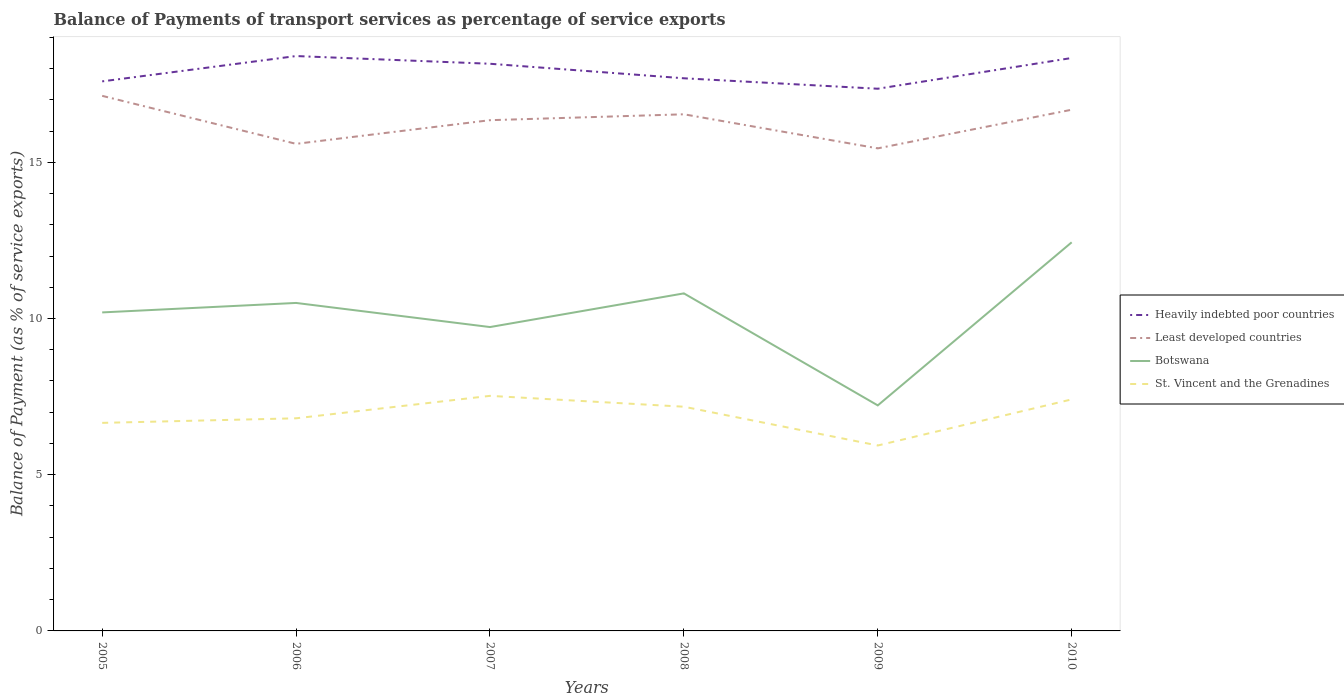How many different coloured lines are there?
Keep it short and to the point. 4. Does the line corresponding to Heavily indebted poor countries intersect with the line corresponding to Botswana?
Provide a short and direct response. No. Across all years, what is the maximum balance of payments of transport services in Botswana?
Offer a terse response. 7.22. What is the total balance of payments of transport services in Least developed countries in the graph?
Your answer should be compact. -1.09. What is the difference between the highest and the second highest balance of payments of transport services in Least developed countries?
Keep it short and to the point. 1.68. How many lines are there?
Give a very brief answer. 4. Are the values on the major ticks of Y-axis written in scientific E-notation?
Give a very brief answer. No. Does the graph contain any zero values?
Ensure brevity in your answer.  No. Does the graph contain grids?
Give a very brief answer. No. Where does the legend appear in the graph?
Provide a succinct answer. Center right. How are the legend labels stacked?
Your answer should be compact. Vertical. What is the title of the graph?
Your answer should be very brief. Balance of Payments of transport services as percentage of service exports. What is the label or title of the X-axis?
Give a very brief answer. Years. What is the label or title of the Y-axis?
Keep it short and to the point. Balance of Payment (as % of service exports). What is the Balance of Payment (as % of service exports) of Heavily indebted poor countries in 2005?
Provide a succinct answer. 17.59. What is the Balance of Payment (as % of service exports) of Least developed countries in 2005?
Your response must be concise. 17.13. What is the Balance of Payment (as % of service exports) in Botswana in 2005?
Your answer should be compact. 10.2. What is the Balance of Payment (as % of service exports) of St. Vincent and the Grenadines in 2005?
Your answer should be compact. 6.66. What is the Balance of Payment (as % of service exports) of Heavily indebted poor countries in 2006?
Offer a terse response. 18.4. What is the Balance of Payment (as % of service exports) in Least developed countries in 2006?
Provide a succinct answer. 15.59. What is the Balance of Payment (as % of service exports) in Botswana in 2006?
Give a very brief answer. 10.5. What is the Balance of Payment (as % of service exports) in St. Vincent and the Grenadines in 2006?
Provide a succinct answer. 6.81. What is the Balance of Payment (as % of service exports) of Heavily indebted poor countries in 2007?
Your response must be concise. 18.15. What is the Balance of Payment (as % of service exports) in Least developed countries in 2007?
Make the answer very short. 16.35. What is the Balance of Payment (as % of service exports) of Botswana in 2007?
Offer a terse response. 9.73. What is the Balance of Payment (as % of service exports) in St. Vincent and the Grenadines in 2007?
Ensure brevity in your answer.  7.52. What is the Balance of Payment (as % of service exports) in Heavily indebted poor countries in 2008?
Your answer should be compact. 17.69. What is the Balance of Payment (as % of service exports) of Least developed countries in 2008?
Offer a terse response. 16.54. What is the Balance of Payment (as % of service exports) in Botswana in 2008?
Keep it short and to the point. 10.8. What is the Balance of Payment (as % of service exports) in St. Vincent and the Grenadines in 2008?
Your answer should be compact. 7.18. What is the Balance of Payment (as % of service exports) in Heavily indebted poor countries in 2009?
Your response must be concise. 17.36. What is the Balance of Payment (as % of service exports) in Least developed countries in 2009?
Keep it short and to the point. 15.45. What is the Balance of Payment (as % of service exports) of Botswana in 2009?
Your answer should be compact. 7.22. What is the Balance of Payment (as % of service exports) of St. Vincent and the Grenadines in 2009?
Make the answer very short. 5.94. What is the Balance of Payment (as % of service exports) of Heavily indebted poor countries in 2010?
Your response must be concise. 18.34. What is the Balance of Payment (as % of service exports) of Least developed countries in 2010?
Make the answer very short. 16.68. What is the Balance of Payment (as % of service exports) of Botswana in 2010?
Keep it short and to the point. 12.44. What is the Balance of Payment (as % of service exports) in St. Vincent and the Grenadines in 2010?
Your answer should be very brief. 7.41. Across all years, what is the maximum Balance of Payment (as % of service exports) of Heavily indebted poor countries?
Keep it short and to the point. 18.4. Across all years, what is the maximum Balance of Payment (as % of service exports) in Least developed countries?
Your answer should be very brief. 17.13. Across all years, what is the maximum Balance of Payment (as % of service exports) of Botswana?
Provide a short and direct response. 12.44. Across all years, what is the maximum Balance of Payment (as % of service exports) of St. Vincent and the Grenadines?
Your answer should be compact. 7.52. Across all years, what is the minimum Balance of Payment (as % of service exports) of Heavily indebted poor countries?
Offer a very short reply. 17.36. Across all years, what is the minimum Balance of Payment (as % of service exports) in Least developed countries?
Offer a very short reply. 15.45. Across all years, what is the minimum Balance of Payment (as % of service exports) of Botswana?
Your answer should be very brief. 7.22. Across all years, what is the minimum Balance of Payment (as % of service exports) of St. Vincent and the Grenadines?
Offer a terse response. 5.94. What is the total Balance of Payment (as % of service exports) of Heavily indebted poor countries in the graph?
Your response must be concise. 107.53. What is the total Balance of Payment (as % of service exports) in Least developed countries in the graph?
Offer a very short reply. 97.73. What is the total Balance of Payment (as % of service exports) in Botswana in the graph?
Provide a succinct answer. 60.88. What is the total Balance of Payment (as % of service exports) in St. Vincent and the Grenadines in the graph?
Give a very brief answer. 41.51. What is the difference between the Balance of Payment (as % of service exports) in Heavily indebted poor countries in 2005 and that in 2006?
Your answer should be very brief. -0.81. What is the difference between the Balance of Payment (as % of service exports) of Least developed countries in 2005 and that in 2006?
Give a very brief answer. 1.54. What is the difference between the Balance of Payment (as % of service exports) in Botswana in 2005 and that in 2006?
Your answer should be compact. -0.3. What is the difference between the Balance of Payment (as % of service exports) of St. Vincent and the Grenadines in 2005 and that in 2006?
Your answer should be very brief. -0.15. What is the difference between the Balance of Payment (as % of service exports) of Heavily indebted poor countries in 2005 and that in 2007?
Give a very brief answer. -0.56. What is the difference between the Balance of Payment (as % of service exports) in Least developed countries in 2005 and that in 2007?
Ensure brevity in your answer.  0.78. What is the difference between the Balance of Payment (as % of service exports) in Botswana in 2005 and that in 2007?
Your answer should be very brief. 0.47. What is the difference between the Balance of Payment (as % of service exports) in St. Vincent and the Grenadines in 2005 and that in 2007?
Offer a very short reply. -0.87. What is the difference between the Balance of Payment (as % of service exports) in Heavily indebted poor countries in 2005 and that in 2008?
Offer a very short reply. -0.1. What is the difference between the Balance of Payment (as % of service exports) in Least developed countries in 2005 and that in 2008?
Make the answer very short. 0.59. What is the difference between the Balance of Payment (as % of service exports) in Botswana in 2005 and that in 2008?
Your answer should be compact. -0.61. What is the difference between the Balance of Payment (as % of service exports) in St. Vincent and the Grenadines in 2005 and that in 2008?
Give a very brief answer. -0.52. What is the difference between the Balance of Payment (as % of service exports) of Heavily indebted poor countries in 2005 and that in 2009?
Offer a very short reply. 0.24. What is the difference between the Balance of Payment (as % of service exports) in Least developed countries in 2005 and that in 2009?
Offer a terse response. 1.68. What is the difference between the Balance of Payment (as % of service exports) in Botswana in 2005 and that in 2009?
Your response must be concise. 2.98. What is the difference between the Balance of Payment (as % of service exports) of St. Vincent and the Grenadines in 2005 and that in 2009?
Provide a short and direct response. 0.72. What is the difference between the Balance of Payment (as % of service exports) in Heavily indebted poor countries in 2005 and that in 2010?
Your answer should be very brief. -0.75. What is the difference between the Balance of Payment (as % of service exports) in Least developed countries in 2005 and that in 2010?
Keep it short and to the point. 0.44. What is the difference between the Balance of Payment (as % of service exports) in Botswana in 2005 and that in 2010?
Your answer should be very brief. -2.24. What is the difference between the Balance of Payment (as % of service exports) of St. Vincent and the Grenadines in 2005 and that in 2010?
Ensure brevity in your answer.  -0.75. What is the difference between the Balance of Payment (as % of service exports) of Heavily indebted poor countries in 2006 and that in 2007?
Your answer should be very brief. 0.25. What is the difference between the Balance of Payment (as % of service exports) of Least developed countries in 2006 and that in 2007?
Offer a very short reply. -0.76. What is the difference between the Balance of Payment (as % of service exports) of Botswana in 2006 and that in 2007?
Provide a succinct answer. 0.77. What is the difference between the Balance of Payment (as % of service exports) of St. Vincent and the Grenadines in 2006 and that in 2007?
Provide a short and direct response. -0.72. What is the difference between the Balance of Payment (as % of service exports) in Heavily indebted poor countries in 2006 and that in 2008?
Keep it short and to the point. 0.71. What is the difference between the Balance of Payment (as % of service exports) in Least developed countries in 2006 and that in 2008?
Make the answer very short. -0.95. What is the difference between the Balance of Payment (as % of service exports) of Botswana in 2006 and that in 2008?
Keep it short and to the point. -0.31. What is the difference between the Balance of Payment (as % of service exports) in St. Vincent and the Grenadines in 2006 and that in 2008?
Keep it short and to the point. -0.37. What is the difference between the Balance of Payment (as % of service exports) of Heavily indebted poor countries in 2006 and that in 2009?
Your response must be concise. 1.05. What is the difference between the Balance of Payment (as % of service exports) in Least developed countries in 2006 and that in 2009?
Provide a succinct answer. 0.14. What is the difference between the Balance of Payment (as % of service exports) of Botswana in 2006 and that in 2009?
Ensure brevity in your answer.  3.28. What is the difference between the Balance of Payment (as % of service exports) of St. Vincent and the Grenadines in 2006 and that in 2009?
Make the answer very short. 0.87. What is the difference between the Balance of Payment (as % of service exports) of Heavily indebted poor countries in 2006 and that in 2010?
Give a very brief answer. 0.06. What is the difference between the Balance of Payment (as % of service exports) in Least developed countries in 2006 and that in 2010?
Offer a terse response. -1.09. What is the difference between the Balance of Payment (as % of service exports) in Botswana in 2006 and that in 2010?
Provide a short and direct response. -1.94. What is the difference between the Balance of Payment (as % of service exports) in St. Vincent and the Grenadines in 2006 and that in 2010?
Your answer should be very brief. -0.61. What is the difference between the Balance of Payment (as % of service exports) in Heavily indebted poor countries in 2007 and that in 2008?
Keep it short and to the point. 0.47. What is the difference between the Balance of Payment (as % of service exports) in Least developed countries in 2007 and that in 2008?
Your answer should be compact. -0.19. What is the difference between the Balance of Payment (as % of service exports) in Botswana in 2007 and that in 2008?
Offer a very short reply. -1.08. What is the difference between the Balance of Payment (as % of service exports) in St. Vincent and the Grenadines in 2007 and that in 2008?
Your response must be concise. 0.35. What is the difference between the Balance of Payment (as % of service exports) in Heavily indebted poor countries in 2007 and that in 2009?
Keep it short and to the point. 0.8. What is the difference between the Balance of Payment (as % of service exports) in Least developed countries in 2007 and that in 2009?
Offer a terse response. 0.9. What is the difference between the Balance of Payment (as % of service exports) of Botswana in 2007 and that in 2009?
Give a very brief answer. 2.51. What is the difference between the Balance of Payment (as % of service exports) of St. Vincent and the Grenadines in 2007 and that in 2009?
Ensure brevity in your answer.  1.59. What is the difference between the Balance of Payment (as % of service exports) in Heavily indebted poor countries in 2007 and that in 2010?
Provide a succinct answer. -0.18. What is the difference between the Balance of Payment (as % of service exports) of Least developed countries in 2007 and that in 2010?
Ensure brevity in your answer.  -0.33. What is the difference between the Balance of Payment (as % of service exports) in Botswana in 2007 and that in 2010?
Keep it short and to the point. -2.71. What is the difference between the Balance of Payment (as % of service exports) in St. Vincent and the Grenadines in 2007 and that in 2010?
Make the answer very short. 0.11. What is the difference between the Balance of Payment (as % of service exports) of Heavily indebted poor countries in 2008 and that in 2009?
Keep it short and to the point. 0.33. What is the difference between the Balance of Payment (as % of service exports) in Least developed countries in 2008 and that in 2009?
Your answer should be very brief. 1.09. What is the difference between the Balance of Payment (as % of service exports) in Botswana in 2008 and that in 2009?
Offer a very short reply. 3.59. What is the difference between the Balance of Payment (as % of service exports) in St. Vincent and the Grenadines in 2008 and that in 2009?
Provide a short and direct response. 1.24. What is the difference between the Balance of Payment (as % of service exports) of Heavily indebted poor countries in 2008 and that in 2010?
Make the answer very short. -0.65. What is the difference between the Balance of Payment (as % of service exports) in Least developed countries in 2008 and that in 2010?
Make the answer very short. -0.15. What is the difference between the Balance of Payment (as % of service exports) in Botswana in 2008 and that in 2010?
Your answer should be very brief. -1.63. What is the difference between the Balance of Payment (as % of service exports) of St. Vincent and the Grenadines in 2008 and that in 2010?
Offer a terse response. -0.23. What is the difference between the Balance of Payment (as % of service exports) of Heavily indebted poor countries in 2009 and that in 2010?
Offer a terse response. -0.98. What is the difference between the Balance of Payment (as % of service exports) in Least developed countries in 2009 and that in 2010?
Make the answer very short. -1.24. What is the difference between the Balance of Payment (as % of service exports) of Botswana in 2009 and that in 2010?
Your response must be concise. -5.22. What is the difference between the Balance of Payment (as % of service exports) of St. Vincent and the Grenadines in 2009 and that in 2010?
Your answer should be compact. -1.48. What is the difference between the Balance of Payment (as % of service exports) of Heavily indebted poor countries in 2005 and the Balance of Payment (as % of service exports) of Least developed countries in 2006?
Keep it short and to the point. 2. What is the difference between the Balance of Payment (as % of service exports) of Heavily indebted poor countries in 2005 and the Balance of Payment (as % of service exports) of Botswana in 2006?
Offer a terse response. 7.09. What is the difference between the Balance of Payment (as % of service exports) of Heavily indebted poor countries in 2005 and the Balance of Payment (as % of service exports) of St. Vincent and the Grenadines in 2006?
Offer a very short reply. 10.78. What is the difference between the Balance of Payment (as % of service exports) of Least developed countries in 2005 and the Balance of Payment (as % of service exports) of Botswana in 2006?
Give a very brief answer. 6.63. What is the difference between the Balance of Payment (as % of service exports) of Least developed countries in 2005 and the Balance of Payment (as % of service exports) of St. Vincent and the Grenadines in 2006?
Make the answer very short. 10.32. What is the difference between the Balance of Payment (as % of service exports) of Botswana in 2005 and the Balance of Payment (as % of service exports) of St. Vincent and the Grenadines in 2006?
Make the answer very short. 3.39. What is the difference between the Balance of Payment (as % of service exports) in Heavily indebted poor countries in 2005 and the Balance of Payment (as % of service exports) in Least developed countries in 2007?
Your answer should be very brief. 1.24. What is the difference between the Balance of Payment (as % of service exports) of Heavily indebted poor countries in 2005 and the Balance of Payment (as % of service exports) of Botswana in 2007?
Give a very brief answer. 7.86. What is the difference between the Balance of Payment (as % of service exports) of Heavily indebted poor countries in 2005 and the Balance of Payment (as % of service exports) of St. Vincent and the Grenadines in 2007?
Your answer should be very brief. 10.07. What is the difference between the Balance of Payment (as % of service exports) of Least developed countries in 2005 and the Balance of Payment (as % of service exports) of Botswana in 2007?
Provide a short and direct response. 7.4. What is the difference between the Balance of Payment (as % of service exports) in Least developed countries in 2005 and the Balance of Payment (as % of service exports) in St. Vincent and the Grenadines in 2007?
Give a very brief answer. 9.6. What is the difference between the Balance of Payment (as % of service exports) of Botswana in 2005 and the Balance of Payment (as % of service exports) of St. Vincent and the Grenadines in 2007?
Your response must be concise. 2.67. What is the difference between the Balance of Payment (as % of service exports) in Heavily indebted poor countries in 2005 and the Balance of Payment (as % of service exports) in Least developed countries in 2008?
Give a very brief answer. 1.05. What is the difference between the Balance of Payment (as % of service exports) of Heavily indebted poor countries in 2005 and the Balance of Payment (as % of service exports) of Botswana in 2008?
Provide a succinct answer. 6.79. What is the difference between the Balance of Payment (as % of service exports) of Heavily indebted poor countries in 2005 and the Balance of Payment (as % of service exports) of St. Vincent and the Grenadines in 2008?
Your answer should be very brief. 10.41. What is the difference between the Balance of Payment (as % of service exports) of Least developed countries in 2005 and the Balance of Payment (as % of service exports) of Botswana in 2008?
Offer a terse response. 6.32. What is the difference between the Balance of Payment (as % of service exports) of Least developed countries in 2005 and the Balance of Payment (as % of service exports) of St. Vincent and the Grenadines in 2008?
Keep it short and to the point. 9.95. What is the difference between the Balance of Payment (as % of service exports) in Botswana in 2005 and the Balance of Payment (as % of service exports) in St. Vincent and the Grenadines in 2008?
Offer a very short reply. 3.02. What is the difference between the Balance of Payment (as % of service exports) in Heavily indebted poor countries in 2005 and the Balance of Payment (as % of service exports) in Least developed countries in 2009?
Offer a very short reply. 2.14. What is the difference between the Balance of Payment (as % of service exports) of Heavily indebted poor countries in 2005 and the Balance of Payment (as % of service exports) of Botswana in 2009?
Provide a short and direct response. 10.37. What is the difference between the Balance of Payment (as % of service exports) in Heavily indebted poor countries in 2005 and the Balance of Payment (as % of service exports) in St. Vincent and the Grenadines in 2009?
Offer a terse response. 11.66. What is the difference between the Balance of Payment (as % of service exports) in Least developed countries in 2005 and the Balance of Payment (as % of service exports) in Botswana in 2009?
Ensure brevity in your answer.  9.91. What is the difference between the Balance of Payment (as % of service exports) in Least developed countries in 2005 and the Balance of Payment (as % of service exports) in St. Vincent and the Grenadines in 2009?
Provide a succinct answer. 11.19. What is the difference between the Balance of Payment (as % of service exports) in Botswana in 2005 and the Balance of Payment (as % of service exports) in St. Vincent and the Grenadines in 2009?
Offer a very short reply. 4.26. What is the difference between the Balance of Payment (as % of service exports) in Heavily indebted poor countries in 2005 and the Balance of Payment (as % of service exports) in Least developed countries in 2010?
Ensure brevity in your answer.  0.91. What is the difference between the Balance of Payment (as % of service exports) of Heavily indebted poor countries in 2005 and the Balance of Payment (as % of service exports) of Botswana in 2010?
Ensure brevity in your answer.  5.15. What is the difference between the Balance of Payment (as % of service exports) of Heavily indebted poor countries in 2005 and the Balance of Payment (as % of service exports) of St. Vincent and the Grenadines in 2010?
Your answer should be compact. 10.18. What is the difference between the Balance of Payment (as % of service exports) of Least developed countries in 2005 and the Balance of Payment (as % of service exports) of Botswana in 2010?
Keep it short and to the point. 4.69. What is the difference between the Balance of Payment (as % of service exports) of Least developed countries in 2005 and the Balance of Payment (as % of service exports) of St. Vincent and the Grenadines in 2010?
Your response must be concise. 9.72. What is the difference between the Balance of Payment (as % of service exports) of Botswana in 2005 and the Balance of Payment (as % of service exports) of St. Vincent and the Grenadines in 2010?
Make the answer very short. 2.78. What is the difference between the Balance of Payment (as % of service exports) of Heavily indebted poor countries in 2006 and the Balance of Payment (as % of service exports) of Least developed countries in 2007?
Ensure brevity in your answer.  2.05. What is the difference between the Balance of Payment (as % of service exports) of Heavily indebted poor countries in 2006 and the Balance of Payment (as % of service exports) of Botswana in 2007?
Your answer should be very brief. 8.67. What is the difference between the Balance of Payment (as % of service exports) in Heavily indebted poor countries in 2006 and the Balance of Payment (as % of service exports) in St. Vincent and the Grenadines in 2007?
Offer a very short reply. 10.88. What is the difference between the Balance of Payment (as % of service exports) in Least developed countries in 2006 and the Balance of Payment (as % of service exports) in Botswana in 2007?
Your response must be concise. 5.86. What is the difference between the Balance of Payment (as % of service exports) of Least developed countries in 2006 and the Balance of Payment (as % of service exports) of St. Vincent and the Grenadines in 2007?
Make the answer very short. 8.07. What is the difference between the Balance of Payment (as % of service exports) of Botswana in 2006 and the Balance of Payment (as % of service exports) of St. Vincent and the Grenadines in 2007?
Ensure brevity in your answer.  2.97. What is the difference between the Balance of Payment (as % of service exports) in Heavily indebted poor countries in 2006 and the Balance of Payment (as % of service exports) in Least developed countries in 2008?
Provide a succinct answer. 1.86. What is the difference between the Balance of Payment (as % of service exports) in Heavily indebted poor countries in 2006 and the Balance of Payment (as % of service exports) in Botswana in 2008?
Offer a very short reply. 7.6. What is the difference between the Balance of Payment (as % of service exports) of Heavily indebted poor countries in 2006 and the Balance of Payment (as % of service exports) of St. Vincent and the Grenadines in 2008?
Offer a very short reply. 11.22. What is the difference between the Balance of Payment (as % of service exports) in Least developed countries in 2006 and the Balance of Payment (as % of service exports) in Botswana in 2008?
Make the answer very short. 4.79. What is the difference between the Balance of Payment (as % of service exports) of Least developed countries in 2006 and the Balance of Payment (as % of service exports) of St. Vincent and the Grenadines in 2008?
Provide a short and direct response. 8.41. What is the difference between the Balance of Payment (as % of service exports) in Botswana in 2006 and the Balance of Payment (as % of service exports) in St. Vincent and the Grenadines in 2008?
Provide a short and direct response. 3.32. What is the difference between the Balance of Payment (as % of service exports) in Heavily indebted poor countries in 2006 and the Balance of Payment (as % of service exports) in Least developed countries in 2009?
Ensure brevity in your answer.  2.95. What is the difference between the Balance of Payment (as % of service exports) in Heavily indebted poor countries in 2006 and the Balance of Payment (as % of service exports) in Botswana in 2009?
Keep it short and to the point. 11.18. What is the difference between the Balance of Payment (as % of service exports) of Heavily indebted poor countries in 2006 and the Balance of Payment (as % of service exports) of St. Vincent and the Grenadines in 2009?
Offer a very short reply. 12.47. What is the difference between the Balance of Payment (as % of service exports) in Least developed countries in 2006 and the Balance of Payment (as % of service exports) in Botswana in 2009?
Give a very brief answer. 8.37. What is the difference between the Balance of Payment (as % of service exports) in Least developed countries in 2006 and the Balance of Payment (as % of service exports) in St. Vincent and the Grenadines in 2009?
Give a very brief answer. 9.66. What is the difference between the Balance of Payment (as % of service exports) of Botswana in 2006 and the Balance of Payment (as % of service exports) of St. Vincent and the Grenadines in 2009?
Provide a succinct answer. 4.56. What is the difference between the Balance of Payment (as % of service exports) of Heavily indebted poor countries in 2006 and the Balance of Payment (as % of service exports) of Least developed countries in 2010?
Provide a succinct answer. 1.72. What is the difference between the Balance of Payment (as % of service exports) in Heavily indebted poor countries in 2006 and the Balance of Payment (as % of service exports) in Botswana in 2010?
Your answer should be very brief. 5.96. What is the difference between the Balance of Payment (as % of service exports) of Heavily indebted poor countries in 2006 and the Balance of Payment (as % of service exports) of St. Vincent and the Grenadines in 2010?
Provide a short and direct response. 10.99. What is the difference between the Balance of Payment (as % of service exports) of Least developed countries in 2006 and the Balance of Payment (as % of service exports) of Botswana in 2010?
Keep it short and to the point. 3.15. What is the difference between the Balance of Payment (as % of service exports) of Least developed countries in 2006 and the Balance of Payment (as % of service exports) of St. Vincent and the Grenadines in 2010?
Offer a very short reply. 8.18. What is the difference between the Balance of Payment (as % of service exports) of Botswana in 2006 and the Balance of Payment (as % of service exports) of St. Vincent and the Grenadines in 2010?
Ensure brevity in your answer.  3.09. What is the difference between the Balance of Payment (as % of service exports) in Heavily indebted poor countries in 2007 and the Balance of Payment (as % of service exports) in Least developed countries in 2008?
Your answer should be very brief. 1.62. What is the difference between the Balance of Payment (as % of service exports) in Heavily indebted poor countries in 2007 and the Balance of Payment (as % of service exports) in Botswana in 2008?
Keep it short and to the point. 7.35. What is the difference between the Balance of Payment (as % of service exports) in Heavily indebted poor countries in 2007 and the Balance of Payment (as % of service exports) in St. Vincent and the Grenadines in 2008?
Provide a succinct answer. 10.98. What is the difference between the Balance of Payment (as % of service exports) of Least developed countries in 2007 and the Balance of Payment (as % of service exports) of Botswana in 2008?
Your response must be concise. 5.54. What is the difference between the Balance of Payment (as % of service exports) of Least developed countries in 2007 and the Balance of Payment (as % of service exports) of St. Vincent and the Grenadines in 2008?
Your response must be concise. 9.17. What is the difference between the Balance of Payment (as % of service exports) of Botswana in 2007 and the Balance of Payment (as % of service exports) of St. Vincent and the Grenadines in 2008?
Provide a succinct answer. 2.55. What is the difference between the Balance of Payment (as % of service exports) of Heavily indebted poor countries in 2007 and the Balance of Payment (as % of service exports) of Least developed countries in 2009?
Your response must be concise. 2.71. What is the difference between the Balance of Payment (as % of service exports) of Heavily indebted poor countries in 2007 and the Balance of Payment (as % of service exports) of Botswana in 2009?
Provide a short and direct response. 10.94. What is the difference between the Balance of Payment (as % of service exports) in Heavily indebted poor countries in 2007 and the Balance of Payment (as % of service exports) in St. Vincent and the Grenadines in 2009?
Offer a terse response. 12.22. What is the difference between the Balance of Payment (as % of service exports) of Least developed countries in 2007 and the Balance of Payment (as % of service exports) of Botswana in 2009?
Offer a very short reply. 9.13. What is the difference between the Balance of Payment (as % of service exports) in Least developed countries in 2007 and the Balance of Payment (as % of service exports) in St. Vincent and the Grenadines in 2009?
Provide a succinct answer. 10.41. What is the difference between the Balance of Payment (as % of service exports) in Botswana in 2007 and the Balance of Payment (as % of service exports) in St. Vincent and the Grenadines in 2009?
Provide a short and direct response. 3.79. What is the difference between the Balance of Payment (as % of service exports) of Heavily indebted poor countries in 2007 and the Balance of Payment (as % of service exports) of Least developed countries in 2010?
Your answer should be compact. 1.47. What is the difference between the Balance of Payment (as % of service exports) of Heavily indebted poor countries in 2007 and the Balance of Payment (as % of service exports) of Botswana in 2010?
Offer a terse response. 5.72. What is the difference between the Balance of Payment (as % of service exports) in Heavily indebted poor countries in 2007 and the Balance of Payment (as % of service exports) in St. Vincent and the Grenadines in 2010?
Provide a succinct answer. 10.74. What is the difference between the Balance of Payment (as % of service exports) in Least developed countries in 2007 and the Balance of Payment (as % of service exports) in Botswana in 2010?
Give a very brief answer. 3.91. What is the difference between the Balance of Payment (as % of service exports) in Least developed countries in 2007 and the Balance of Payment (as % of service exports) in St. Vincent and the Grenadines in 2010?
Offer a very short reply. 8.94. What is the difference between the Balance of Payment (as % of service exports) in Botswana in 2007 and the Balance of Payment (as % of service exports) in St. Vincent and the Grenadines in 2010?
Keep it short and to the point. 2.32. What is the difference between the Balance of Payment (as % of service exports) of Heavily indebted poor countries in 2008 and the Balance of Payment (as % of service exports) of Least developed countries in 2009?
Your answer should be very brief. 2.24. What is the difference between the Balance of Payment (as % of service exports) in Heavily indebted poor countries in 2008 and the Balance of Payment (as % of service exports) in Botswana in 2009?
Offer a terse response. 10.47. What is the difference between the Balance of Payment (as % of service exports) in Heavily indebted poor countries in 2008 and the Balance of Payment (as % of service exports) in St. Vincent and the Grenadines in 2009?
Give a very brief answer. 11.75. What is the difference between the Balance of Payment (as % of service exports) of Least developed countries in 2008 and the Balance of Payment (as % of service exports) of Botswana in 2009?
Provide a short and direct response. 9.32. What is the difference between the Balance of Payment (as % of service exports) in Least developed countries in 2008 and the Balance of Payment (as % of service exports) in St. Vincent and the Grenadines in 2009?
Ensure brevity in your answer.  10.6. What is the difference between the Balance of Payment (as % of service exports) of Botswana in 2008 and the Balance of Payment (as % of service exports) of St. Vincent and the Grenadines in 2009?
Offer a very short reply. 4.87. What is the difference between the Balance of Payment (as % of service exports) of Heavily indebted poor countries in 2008 and the Balance of Payment (as % of service exports) of Least developed countries in 2010?
Offer a very short reply. 1.01. What is the difference between the Balance of Payment (as % of service exports) of Heavily indebted poor countries in 2008 and the Balance of Payment (as % of service exports) of Botswana in 2010?
Provide a succinct answer. 5.25. What is the difference between the Balance of Payment (as % of service exports) in Heavily indebted poor countries in 2008 and the Balance of Payment (as % of service exports) in St. Vincent and the Grenadines in 2010?
Your answer should be compact. 10.28. What is the difference between the Balance of Payment (as % of service exports) of Least developed countries in 2008 and the Balance of Payment (as % of service exports) of Botswana in 2010?
Keep it short and to the point. 4.1. What is the difference between the Balance of Payment (as % of service exports) in Least developed countries in 2008 and the Balance of Payment (as % of service exports) in St. Vincent and the Grenadines in 2010?
Offer a very short reply. 9.13. What is the difference between the Balance of Payment (as % of service exports) in Botswana in 2008 and the Balance of Payment (as % of service exports) in St. Vincent and the Grenadines in 2010?
Offer a very short reply. 3.39. What is the difference between the Balance of Payment (as % of service exports) in Heavily indebted poor countries in 2009 and the Balance of Payment (as % of service exports) in Least developed countries in 2010?
Give a very brief answer. 0.67. What is the difference between the Balance of Payment (as % of service exports) in Heavily indebted poor countries in 2009 and the Balance of Payment (as % of service exports) in Botswana in 2010?
Keep it short and to the point. 4.92. What is the difference between the Balance of Payment (as % of service exports) of Heavily indebted poor countries in 2009 and the Balance of Payment (as % of service exports) of St. Vincent and the Grenadines in 2010?
Provide a short and direct response. 9.94. What is the difference between the Balance of Payment (as % of service exports) of Least developed countries in 2009 and the Balance of Payment (as % of service exports) of Botswana in 2010?
Your answer should be compact. 3.01. What is the difference between the Balance of Payment (as % of service exports) in Least developed countries in 2009 and the Balance of Payment (as % of service exports) in St. Vincent and the Grenadines in 2010?
Offer a very short reply. 8.04. What is the difference between the Balance of Payment (as % of service exports) in Botswana in 2009 and the Balance of Payment (as % of service exports) in St. Vincent and the Grenadines in 2010?
Make the answer very short. -0.19. What is the average Balance of Payment (as % of service exports) in Heavily indebted poor countries per year?
Provide a succinct answer. 17.92. What is the average Balance of Payment (as % of service exports) in Least developed countries per year?
Ensure brevity in your answer.  16.29. What is the average Balance of Payment (as % of service exports) in Botswana per year?
Ensure brevity in your answer.  10.15. What is the average Balance of Payment (as % of service exports) in St. Vincent and the Grenadines per year?
Offer a very short reply. 6.92. In the year 2005, what is the difference between the Balance of Payment (as % of service exports) in Heavily indebted poor countries and Balance of Payment (as % of service exports) in Least developed countries?
Provide a succinct answer. 0.46. In the year 2005, what is the difference between the Balance of Payment (as % of service exports) in Heavily indebted poor countries and Balance of Payment (as % of service exports) in Botswana?
Your answer should be compact. 7.4. In the year 2005, what is the difference between the Balance of Payment (as % of service exports) of Heavily indebted poor countries and Balance of Payment (as % of service exports) of St. Vincent and the Grenadines?
Your response must be concise. 10.93. In the year 2005, what is the difference between the Balance of Payment (as % of service exports) of Least developed countries and Balance of Payment (as % of service exports) of Botswana?
Provide a succinct answer. 6.93. In the year 2005, what is the difference between the Balance of Payment (as % of service exports) in Least developed countries and Balance of Payment (as % of service exports) in St. Vincent and the Grenadines?
Make the answer very short. 10.47. In the year 2005, what is the difference between the Balance of Payment (as % of service exports) of Botswana and Balance of Payment (as % of service exports) of St. Vincent and the Grenadines?
Keep it short and to the point. 3.54. In the year 2006, what is the difference between the Balance of Payment (as % of service exports) in Heavily indebted poor countries and Balance of Payment (as % of service exports) in Least developed countries?
Provide a succinct answer. 2.81. In the year 2006, what is the difference between the Balance of Payment (as % of service exports) in Heavily indebted poor countries and Balance of Payment (as % of service exports) in Botswana?
Your answer should be compact. 7.9. In the year 2006, what is the difference between the Balance of Payment (as % of service exports) in Heavily indebted poor countries and Balance of Payment (as % of service exports) in St. Vincent and the Grenadines?
Offer a very short reply. 11.6. In the year 2006, what is the difference between the Balance of Payment (as % of service exports) in Least developed countries and Balance of Payment (as % of service exports) in Botswana?
Provide a succinct answer. 5.09. In the year 2006, what is the difference between the Balance of Payment (as % of service exports) in Least developed countries and Balance of Payment (as % of service exports) in St. Vincent and the Grenadines?
Provide a succinct answer. 8.79. In the year 2006, what is the difference between the Balance of Payment (as % of service exports) of Botswana and Balance of Payment (as % of service exports) of St. Vincent and the Grenadines?
Keep it short and to the point. 3.69. In the year 2007, what is the difference between the Balance of Payment (as % of service exports) of Heavily indebted poor countries and Balance of Payment (as % of service exports) of Least developed countries?
Provide a succinct answer. 1.81. In the year 2007, what is the difference between the Balance of Payment (as % of service exports) of Heavily indebted poor countries and Balance of Payment (as % of service exports) of Botswana?
Keep it short and to the point. 8.43. In the year 2007, what is the difference between the Balance of Payment (as % of service exports) of Heavily indebted poor countries and Balance of Payment (as % of service exports) of St. Vincent and the Grenadines?
Keep it short and to the point. 10.63. In the year 2007, what is the difference between the Balance of Payment (as % of service exports) in Least developed countries and Balance of Payment (as % of service exports) in Botswana?
Offer a very short reply. 6.62. In the year 2007, what is the difference between the Balance of Payment (as % of service exports) in Least developed countries and Balance of Payment (as % of service exports) in St. Vincent and the Grenadines?
Your answer should be very brief. 8.82. In the year 2007, what is the difference between the Balance of Payment (as % of service exports) of Botswana and Balance of Payment (as % of service exports) of St. Vincent and the Grenadines?
Your answer should be compact. 2.2. In the year 2008, what is the difference between the Balance of Payment (as % of service exports) in Heavily indebted poor countries and Balance of Payment (as % of service exports) in Least developed countries?
Provide a succinct answer. 1.15. In the year 2008, what is the difference between the Balance of Payment (as % of service exports) of Heavily indebted poor countries and Balance of Payment (as % of service exports) of Botswana?
Make the answer very short. 6.89. In the year 2008, what is the difference between the Balance of Payment (as % of service exports) of Heavily indebted poor countries and Balance of Payment (as % of service exports) of St. Vincent and the Grenadines?
Offer a very short reply. 10.51. In the year 2008, what is the difference between the Balance of Payment (as % of service exports) of Least developed countries and Balance of Payment (as % of service exports) of Botswana?
Make the answer very short. 5.73. In the year 2008, what is the difference between the Balance of Payment (as % of service exports) of Least developed countries and Balance of Payment (as % of service exports) of St. Vincent and the Grenadines?
Make the answer very short. 9.36. In the year 2008, what is the difference between the Balance of Payment (as % of service exports) of Botswana and Balance of Payment (as % of service exports) of St. Vincent and the Grenadines?
Give a very brief answer. 3.63. In the year 2009, what is the difference between the Balance of Payment (as % of service exports) in Heavily indebted poor countries and Balance of Payment (as % of service exports) in Least developed countries?
Your answer should be very brief. 1.91. In the year 2009, what is the difference between the Balance of Payment (as % of service exports) in Heavily indebted poor countries and Balance of Payment (as % of service exports) in Botswana?
Make the answer very short. 10.14. In the year 2009, what is the difference between the Balance of Payment (as % of service exports) of Heavily indebted poor countries and Balance of Payment (as % of service exports) of St. Vincent and the Grenadines?
Your response must be concise. 11.42. In the year 2009, what is the difference between the Balance of Payment (as % of service exports) of Least developed countries and Balance of Payment (as % of service exports) of Botswana?
Offer a terse response. 8.23. In the year 2009, what is the difference between the Balance of Payment (as % of service exports) of Least developed countries and Balance of Payment (as % of service exports) of St. Vincent and the Grenadines?
Ensure brevity in your answer.  9.51. In the year 2009, what is the difference between the Balance of Payment (as % of service exports) of Botswana and Balance of Payment (as % of service exports) of St. Vincent and the Grenadines?
Provide a short and direct response. 1.28. In the year 2010, what is the difference between the Balance of Payment (as % of service exports) of Heavily indebted poor countries and Balance of Payment (as % of service exports) of Least developed countries?
Provide a succinct answer. 1.66. In the year 2010, what is the difference between the Balance of Payment (as % of service exports) in Heavily indebted poor countries and Balance of Payment (as % of service exports) in Botswana?
Offer a terse response. 5.9. In the year 2010, what is the difference between the Balance of Payment (as % of service exports) in Heavily indebted poor countries and Balance of Payment (as % of service exports) in St. Vincent and the Grenadines?
Ensure brevity in your answer.  10.93. In the year 2010, what is the difference between the Balance of Payment (as % of service exports) in Least developed countries and Balance of Payment (as % of service exports) in Botswana?
Keep it short and to the point. 4.24. In the year 2010, what is the difference between the Balance of Payment (as % of service exports) of Least developed countries and Balance of Payment (as % of service exports) of St. Vincent and the Grenadines?
Provide a short and direct response. 9.27. In the year 2010, what is the difference between the Balance of Payment (as % of service exports) of Botswana and Balance of Payment (as % of service exports) of St. Vincent and the Grenadines?
Your answer should be compact. 5.03. What is the ratio of the Balance of Payment (as % of service exports) of Heavily indebted poor countries in 2005 to that in 2006?
Keep it short and to the point. 0.96. What is the ratio of the Balance of Payment (as % of service exports) in Least developed countries in 2005 to that in 2006?
Offer a very short reply. 1.1. What is the ratio of the Balance of Payment (as % of service exports) of Botswana in 2005 to that in 2006?
Offer a terse response. 0.97. What is the ratio of the Balance of Payment (as % of service exports) in St. Vincent and the Grenadines in 2005 to that in 2006?
Offer a very short reply. 0.98. What is the ratio of the Balance of Payment (as % of service exports) of Heavily indebted poor countries in 2005 to that in 2007?
Provide a short and direct response. 0.97. What is the ratio of the Balance of Payment (as % of service exports) in Least developed countries in 2005 to that in 2007?
Offer a terse response. 1.05. What is the ratio of the Balance of Payment (as % of service exports) in Botswana in 2005 to that in 2007?
Your response must be concise. 1.05. What is the ratio of the Balance of Payment (as % of service exports) in St. Vincent and the Grenadines in 2005 to that in 2007?
Ensure brevity in your answer.  0.89. What is the ratio of the Balance of Payment (as % of service exports) of Least developed countries in 2005 to that in 2008?
Make the answer very short. 1.04. What is the ratio of the Balance of Payment (as % of service exports) of Botswana in 2005 to that in 2008?
Ensure brevity in your answer.  0.94. What is the ratio of the Balance of Payment (as % of service exports) in St. Vincent and the Grenadines in 2005 to that in 2008?
Provide a short and direct response. 0.93. What is the ratio of the Balance of Payment (as % of service exports) of Heavily indebted poor countries in 2005 to that in 2009?
Your answer should be compact. 1.01. What is the ratio of the Balance of Payment (as % of service exports) in Least developed countries in 2005 to that in 2009?
Provide a short and direct response. 1.11. What is the ratio of the Balance of Payment (as % of service exports) in Botswana in 2005 to that in 2009?
Your response must be concise. 1.41. What is the ratio of the Balance of Payment (as % of service exports) in St. Vincent and the Grenadines in 2005 to that in 2009?
Your answer should be compact. 1.12. What is the ratio of the Balance of Payment (as % of service exports) of Heavily indebted poor countries in 2005 to that in 2010?
Offer a very short reply. 0.96. What is the ratio of the Balance of Payment (as % of service exports) in Least developed countries in 2005 to that in 2010?
Make the answer very short. 1.03. What is the ratio of the Balance of Payment (as % of service exports) of Botswana in 2005 to that in 2010?
Ensure brevity in your answer.  0.82. What is the ratio of the Balance of Payment (as % of service exports) of St. Vincent and the Grenadines in 2005 to that in 2010?
Your answer should be compact. 0.9. What is the ratio of the Balance of Payment (as % of service exports) in Heavily indebted poor countries in 2006 to that in 2007?
Offer a terse response. 1.01. What is the ratio of the Balance of Payment (as % of service exports) in Least developed countries in 2006 to that in 2007?
Your answer should be very brief. 0.95. What is the ratio of the Balance of Payment (as % of service exports) of Botswana in 2006 to that in 2007?
Offer a very short reply. 1.08. What is the ratio of the Balance of Payment (as % of service exports) of St. Vincent and the Grenadines in 2006 to that in 2007?
Offer a very short reply. 0.9. What is the ratio of the Balance of Payment (as % of service exports) of Heavily indebted poor countries in 2006 to that in 2008?
Your response must be concise. 1.04. What is the ratio of the Balance of Payment (as % of service exports) in Least developed countries in 2006 to that in 2008?
Make the answer very short. 0.94. What is the ratio of the Balance of Payment (as % of service exports) of Botswana in 2006 to that in 2008?
Provide a succinct answer. 0.97. What is the ratio of the Balance of Payment (as % of service exports) of St. Vincent and the Grenadines in 2006 to that in 2008?
Make the answer very short. 0.95. What is the ratio of the Balance of Payment (as % of service exports) in Heavily indebted poor countries in 2006 to that in 2009?
Your answer should be very brief. 1.06. What is the ratio of the Balance of Payment (as % of service exports) of Least developed countries in 2006 to that in 2009?
Your answer should be compact. 1.01. What is the ratio of the Balance of Payment (as % of service exports) of Botswana in 2006 to that in 2009?
Provide a short and direct response. 1.45. What is the ratio of the Balance of Payment (as % of service exports) in St. Vincent and the Grenadines in 2006 to that in 2009?
Offer a terse response. 1.15. What is the ratio of the Balance of Payment (as % of service exports) of Least developed countries in 2006 to that in 2010?
Your response must be concise. 0.93. What is the ratio of the Balance of Payment (as % of service exports) in Botswana in 2006 to that in 2010?
Keep it short and to the point. 0.84. What is the ratio of the Balance of Payment (as % of service exports) of St. Vincent and the Grenadines in 2006 to that in 2010?
Keep it short and to the point. 0.92. What is the ratio of the Balance of Payment (as % of service exports) in Heavily indebted poor countries in 2007 to that in 2008?
Your answer should be compact. 1.03. What is the ratio of the Balance of Payment (as % of service exports) of Botswana in 2007 to that in 2008?
Make the answer very short. 0.9. What is the ratio of the Balance of Payment (as % of service exports) in St. Vincent and the Grenadines in 2007 to that in 2008?
Offer a terse response. 1.05. What is the ratio of the Balance of Payment (as % of service exports) in Heavily indebted poor countries in 2007 to that in 2009?
Give a very brief answer. 1.05. What is the ratio of the Balance of Payment (as % of service exports) of Least developed countries in 2007 to that in 2009?
Your response must be concise. 1.06. What is the ratio of the Balance of Payment (as % of service exports) of Botswana in 2007 to that in 2009?
Your answer should be very brief. 1.35. What is the ratio of the Balance of Payment (as % of service exports) of St. Vincent and the Grenadines in 2007 to that in 2009?
Your answer should be very brief. 1.27. What is the ratio of the Balance of Payment (as % of service exports) in Heavily indebted poor countries in 2007 to that in 2010?
Offer a very short reply. 0.99. What is the ratio of the Balance of Payment (as % of service exports) of Least developed countries in 2007 to that in 2010?
Give a very brief answer. 0.98. What is the ratio of the Balance of Payment (as % of service exports) of Botswana in 2007 to that in 2010?
Offer a very short reply. 0.78. What is the ratio of the Balance of Payment (as % of service exports) of St. Vincent and the Grenadines in 2007 to that in 2010?
Provide a short and direct response. 1.02. What is the ratio of the Balance of Payment (as % of service exports) of Heavily indebted poor countries in 2008 to that in 2009?
Offer a very short reply. 1.02. What is the ratio of the Balance of Payment (as % of service exports) in Least developed countries in 2008 to that in 2009?
Offer a terse response. 1.07. What is the ratio of the Balance of Payment (as % of service exports) in Botswana in 2008 to that in 2009?
Your answer should be very brief. 1.5. What is the ratio of the Balance of Payment (as % of service exports) in St. Vincent and the Grenadines in 2008 to that in 2009?
Keep it short and to the point. 1.21. What is the ratio of the Balance of Payment (as % of service exports) of Heavily indebted poor countries in 2008 to that in 2010?
Your response must be concise. 0.96. What is the ratio of the Balance of Payment (as % of service exports) in Least developed countries in 2008 to that in 2010?
Make the answer very short. 0.99. What is the ratio of the Balance of Payment (as % of service exports) in Botswana in 2008 to that in 2010?
Keep it short and to the point. 0.87. What is the ratio of the Balance of Payment (as % of service exports) in St. Vincent and the Grenadines in 2008 to that in 2010?
Ensure brevity in your answer.  0.97. What is the ratio of the Balance of Payment (as % of service exports) in Heavily indebted poor countries in 2009 to that in 2010?
Give a very brief answer. 0.95. What is the ratio of the Balance of Payment (as % of service exports) of Least developed countries in 2009 to that in 2010?
Your answer should be compact. 0.93. What is the ratio of the Balance of Payment (as % of service exports) of Botswana in 2009 to that in 2010?
Give a very brief answer. 0.58. What is the ratio of the Balance of Payment (as % of service exports) of St. Vincent and the Grenadines in 2009 to that in 2010?
Provide a succinct answer. 0.8. What is the difference between the highest and the second highest Balance of Payment (as % of service exports) of Heavily indebted poor countries?
Keep it short and to the point. 0.06. What is the difference between the highest and the second highest Balance of Payment (as % of service exports) in Least developed countries?
Make the answer very short. 0.44. What is the difference between the highest and the second highest Balance of Payment (as % of service exports) in Botswana?
Offer a terse response. 1.63. What is the difference between the highest and the second highest Balance of Payment (as % of service exports) of St. Vincent and the Grenadines?
Give a very brief answer. 0.11. What is the difference between the highest and the lowest Balance of Payment (as % of service exports) of Heavily indebted poor countries?
Offer a terse response. 1.05. What is the difference between the highest and the lowest Balance of Payment (as % of service exports) in Least developed countries?
Give a very brief answer. 1.68. What is the difference between the highest and the lowest Balance of Payment (as % of service exports) in Botswana?
Your answer should be compact. 5.22. What is the difference between the highest and the lowest Balance of Payment (as % of service exports) of St. Vincent and the Grenadines?
Your answer should be compact. 1.59. 